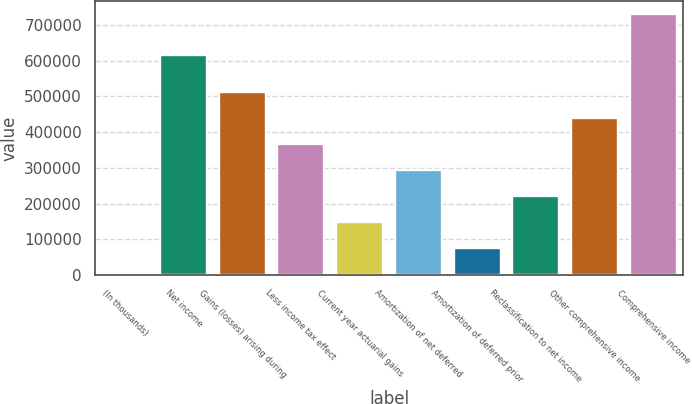<chart> <loc_0><loc_0><loc_500><loc_500><bar_chart><fcel>(In thousands)<fcel>Net income<fcel>Gains (losses) arising during<fcel>Less income tax effect<fcel>Current year actuarial gains<fcel>Amortization of net deferred<fcel>Amortization of deferred prior<fcel>Reclassification to net income<fcel>Other comprehensive income<fcel>Comprehensive income<nl><fcel>2017<fcel>614923<fcel>511777<fcel>366132<fcel>147663<fcel>293309<fcel>74839.9<fcel>220486<fcel>438954<fcel>730246<nl></chart> 